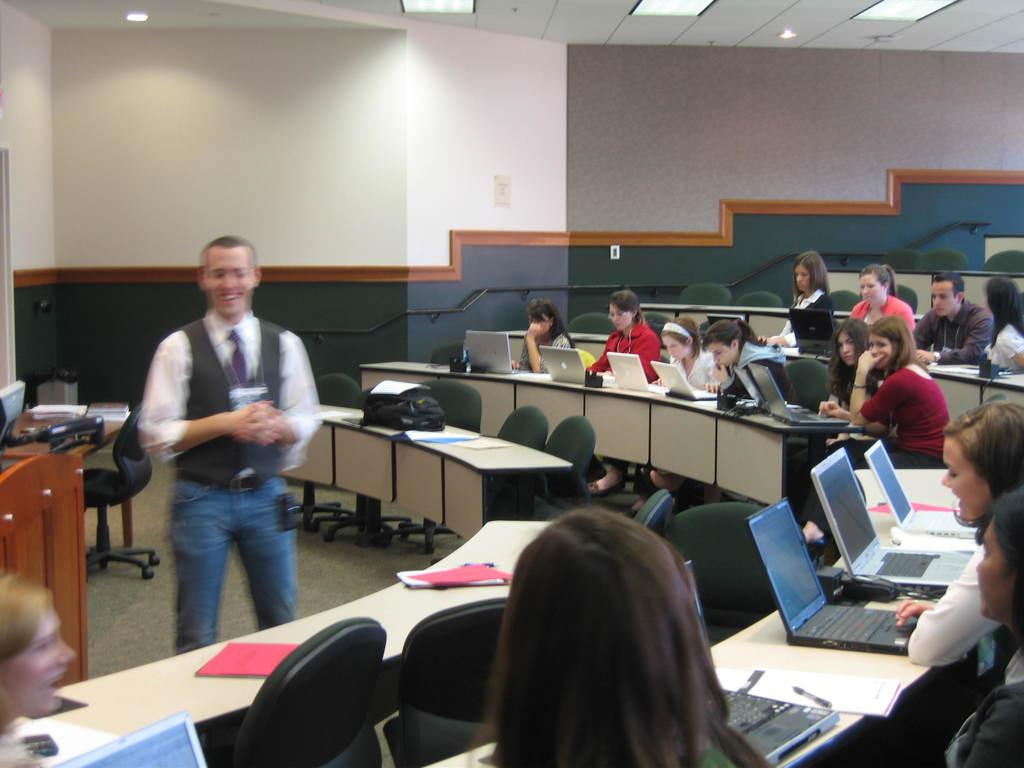What is the color of the wall in the image? The wall in the image is white. Who or what can be seen in the image? There are people in the image. What type of furniture is present in the image? There are tables in the image. What items are on the tables? Laptops, bags, books, and papers are on the tables. What type of attraction can be seen in the image? There is no attraction present in the image. 